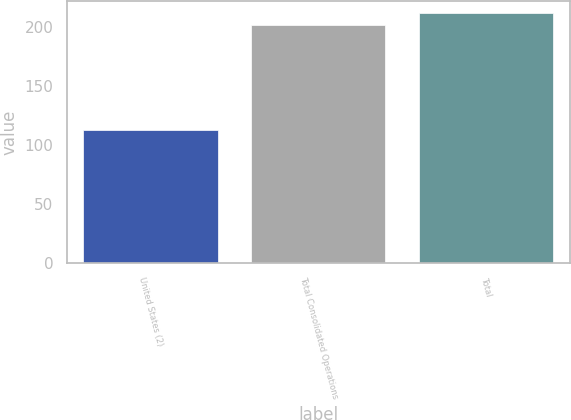Convert chart. <chart><loc_0><loc_0><loc_500><loc_500><bar_chart><fcel>United States (2)<fcel>Total Consolidated Operations<fcel>Total<nl><fcel>113<fcel>202<fcel>211.7<nl></chart> 